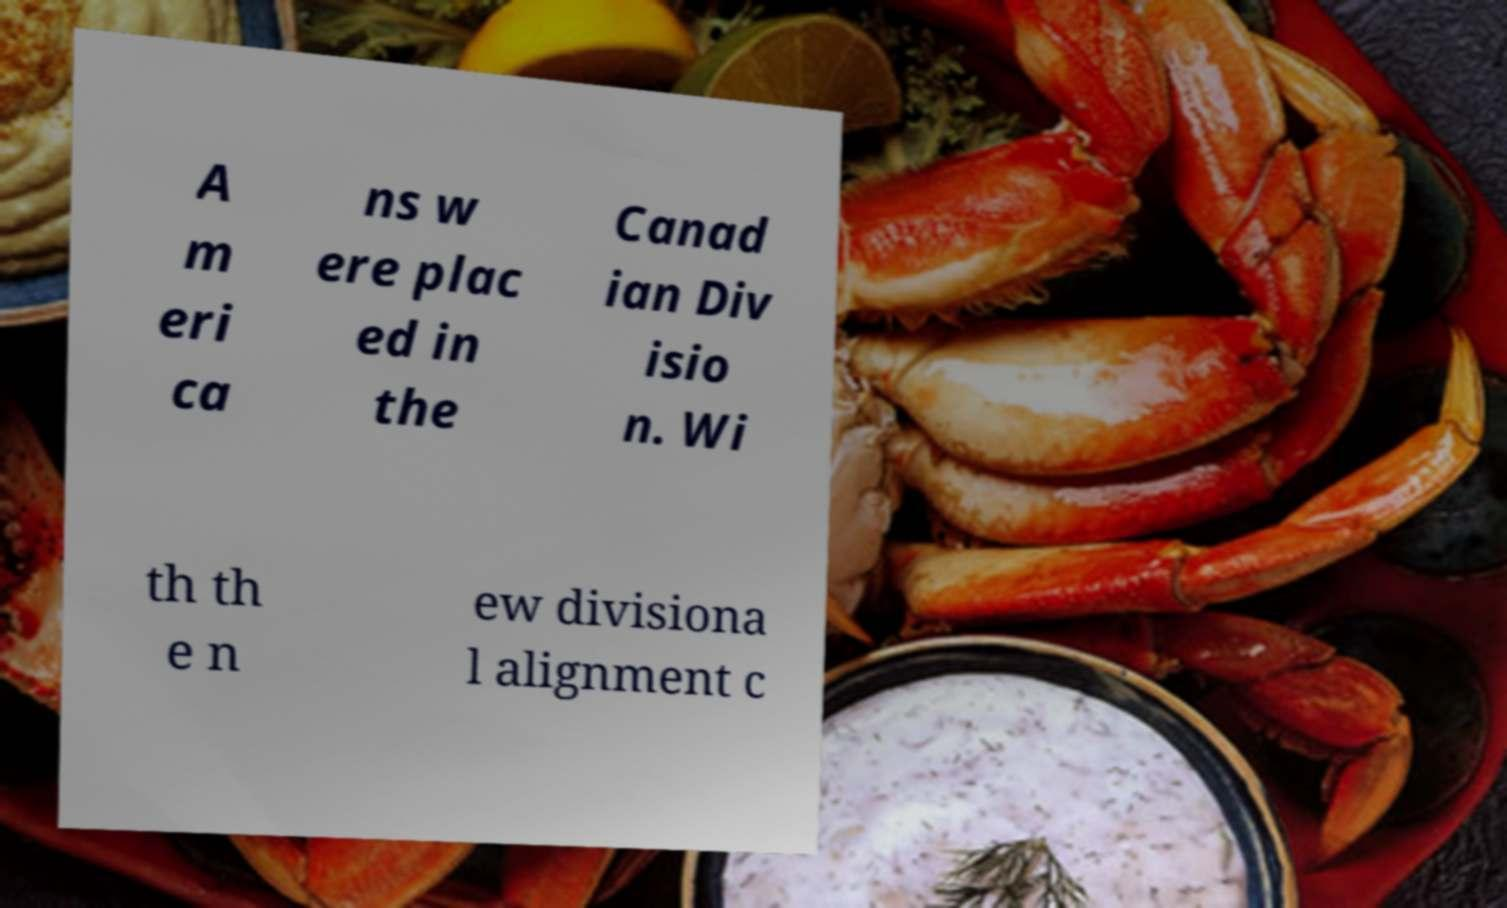Can you read and provide the text displayed in the image?This photo seems to have some interesting text. Can you extract and type it out for me? A m eri ca ns w ere plac ed in the Canad ian Div isio n. Wi th th e n ew divisiona l alignment c 